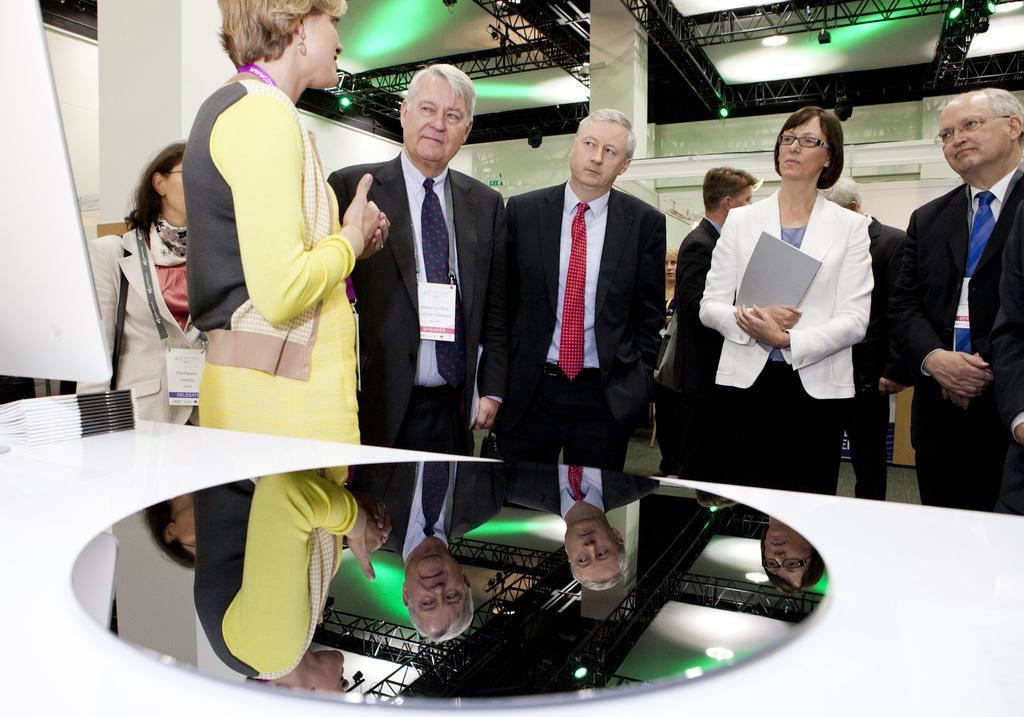In one or two sentences, can you explain what this image depicts? In this image there are group of officers standing on the floor and listening to the woman who is talking in front of them. At the bottom there is a table on which there is a mirror. At the top there are stands with the lights. On the left side there is a board. On the table there are books. 